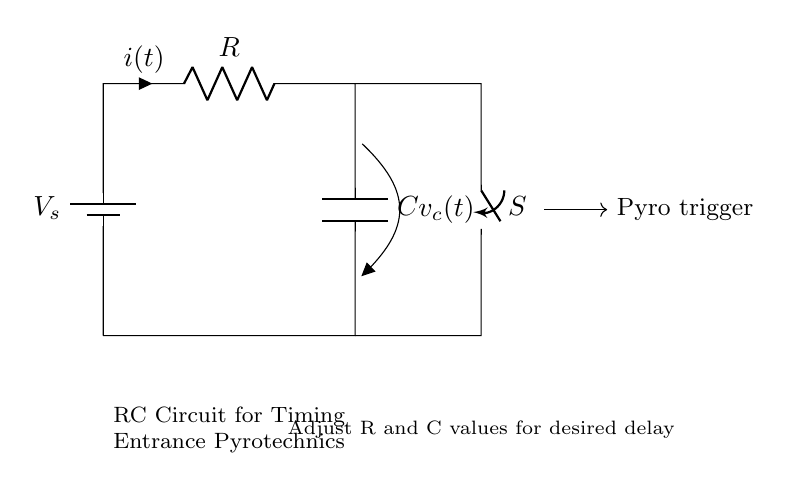What type of circuit is depicted? The circuit shows a Resistor-Capacitor (RC) circuit, characterized by the inclusion of a resistor and a capacitor, which is used for timing functions.
Answer: RC circuit What do the letters R and C represent? R represents the resistance in ohms, while C represents the capacitance in farads. These are the two primary components in an RC circuit, essential for determining the timing characteristics.
Answer: Resistance and Capacitance What is the role of the switch in the circuit? The switch allows for the control of the circuit. When closed, it enables current to flow, charging the capacitor and ultimately triggering the pyro mechanism.
Answer: Control How does the timing delay adjust in this circuit? Timing delay can be adjusted by varying the values of the resistor and capacitor. The time constant, which dictates the delay, is calculated as the product of R and C (tau = R * C).
Answer: Adjust R and C What is the function of the pyro trigger? The pyro trigger is connected to the circuit and activates pyrotechnics when specific voltage or current conditions are met due to the charging of the capacitor over time.
Answer: Activation of pyrotechnics What happens when the switch is closed? Closing the switch allows current to flow, which begins to charge the capacitor. As the capacitor charges, the voltage across it rises, eventually reaching a threshold that activates the pyro trigger.
Answer: Current flows, charges capacitor What does the voltage across the capacitor represent? The voltage across the capacitor indicates the stored electrical energy, which can be used to trigger the pyro mechanism once it reaches the triggering level.
Answer: Stored voltage 